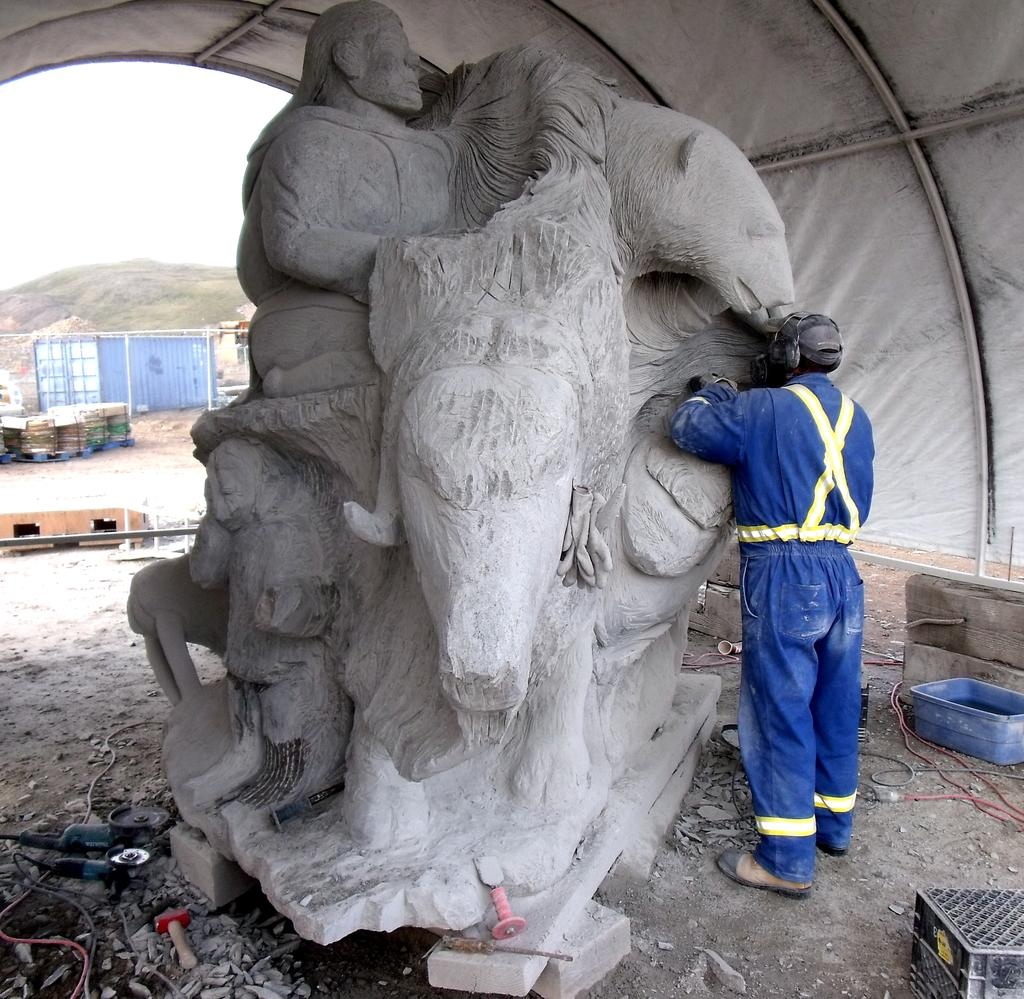What is the main subject in the image? There is a person standing in the image. What else can be seen in the image besides the person? There is a sculpture, tools, a box, a tent, and various objects in the image. Can you describe the background of the image? There is a hill and sky visible in the background of the image, along with some objects. What type of country is depicted in the image? There is no country depicted in the image; it is a scene featuring a person, sculpture, tools, box, tent, and objects, with a hill and sky in the background. 